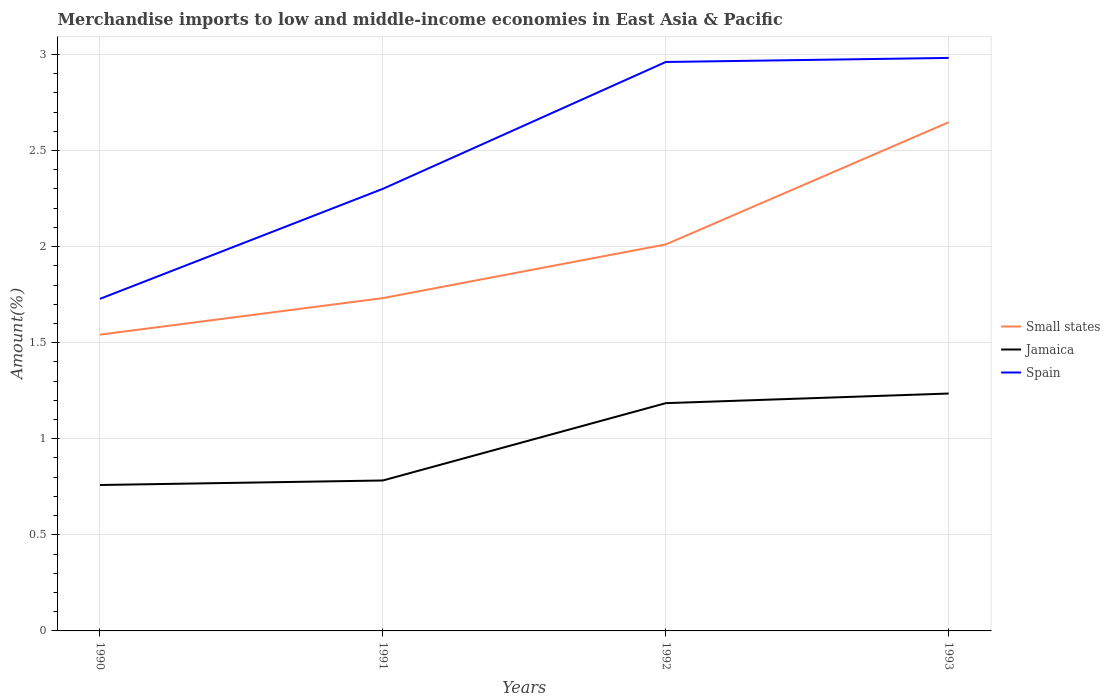Does the line corresponding to Small states intersect with the line corresponding to Spain?
Give a very brief answer. No. Across all years, what is the maximum percentage of amount earned from merchandise imports in Jamaica?
Provide a succinct answer. 0.76. What is the total percentage of amount earned from merchandise imports in Spain in the graph?
Your response must be concise. -0.68. What is the difference between the highest and the second highest percentage of amount earned from merchandise imports in Small states?
Provide a short and direct response. 1.11. What is the difference between two consecutive major ticks on the Y-axis?
Ensure brevity in your answer.  0.5. Are the values on the major ticks of Y-axis written in scientific E-notation?
Your answer should be very brief. No. Does the graph contain any zero values?
Offer a terse response. No. How many legend labels are there?
Give a very brief answer. 3. What is the title of the graph?
Your response must be concise. Merchandise imports to low and middle-income economies in East Asia & Pacific. Does "Albania" appear as one of the legend labels in the graph?
Provide a short and direct response. No. What is the label or title of the Y-axis?
Your response must be concise. Amount(%). What is the Amount(%) in Small states in 1990?
Ensure brevity in your answer.  1.54. What is the Amount(%) of Jamaica in 1990?
Keep it short and to the point. 0.76. What is the Amount(%) in Spain in 1990?
Provide a succinct answer. 1.73. What is the Amount(%) in Small states in 1991?
Offer a very short reply. 1.73. What is the Amount(%) of Jamaica in 1991?
Offer a terse response. 0.78. What is the Amount(%) of Spain in 1991?
Offer a terse response. 2.3. What is the Amount(%) in Small states in 1992?
Ensure brevity in your answer.  2.01. What is the Amount(%) in Jamaica in 1992?
Offer a terse response. 1.19. What is the Amount(%) of Spain in 1992?
Make the answer very short. 2.96. What is the Amount(%) in Small states in 1993?
Your response must be concise. 2.65. What is the Amount(%) of Jamaica in 1993?
Your answer should be very brief. 1.24. What is the Amount(%) of Spain in 1993?
Your answer should be compact. 2.98. Across all years, what is the maximum Amount(%) of Small states?
Offer a terse response. 2.65. Across all years, what is the maximum Amount(%) in Jamaica?
Provide a short and direct response. 1.24. Across all years, what is the maximum Amount(%) in Spain?
Give a very brief answer. 2.98. Across all years, what is the minimum Amount(%) in Small states?
Keep it short and to the point. 1.54. Across all years, what is the minimum Amount(%) of Jamaica?
Offer a very short reply. 0.76. Across all years, what is the minimum Amount(%) in Spain?
Ensure brevity in your answer.  1.73. What is the total Amount(%) in Small states in the graph?
Your answer should be compact. 7.93. What is the total Amount(%) of Jamaica in the graph?
Your response must be concise. 3.96. What is the total Amount(%) in Spain in the graph?
Keep it short and to the point. 9.97. What is the difference between the Amount(%) of Small states in 1990 and that in 1991?
Your response must be concise. -0.19. What is the difference between the Amount(%) in Jamaica in 1990 and that in 1991?
Your response must be concise. -0.02. What is the difference between the Amount(%) in Spain in 1990 and that in 1991?
Make the answer very short. -0.57. What is the difference between the Amount(%) of Small states in 1990 and that in 1992?
Provide a short and direct response. -0.47. What is the difference between the Amount(%) in Jamaica in 1990 and that in 1992?
Provide a short and direct response. -0.43. What is the difference between the Amount(%) of Spain in 1990 and that in 1992?
Ensure brevity in your answer.  -1.23. What is the difference between the Amount(%) of Small states in 1990 and that in 1993?
Ensure brevity in your answer.  -1.11. What is the difference between the Amount(%) of Jamaica in 1990 and that in 1993?
Make the answer very short. -0.48. What is the difference between the Amount(%) in Spain in 1990 and that in 1993?
Make the answer very short. -1.25. What is the difference between the Amount(%) of Small states in 1991 and that in 1992?
Give a very brief answer. -0.28. What is the difference between the Amount(%) in Jamaica in 1991 and that in 1992?
Provide a succinct answer. -0.4. What is the difference between the Amount(%) in Spain in 1991 and that in 1992?
Provide a succinct answer. -0.66. What is the difference between the Amount(%) in Small states in 1991 and that in 1993?
Offer a very short reply. -0.92. What is the difference between the Amount(%) of Jamaica in 1991 and that in 1993?
Provide a succinct answer. -0.45. What is the difference between the Amount(%) in Spain in 1991 and that in 1993?
Keep it short and to the point. -0.68. What is the difference between the Amount(%) in Small states in 1992 and that in 1993?
Your answer should be very brief. -0.64. What is the difference between the Amount(%) of Jamaica in 1992 and that in 1993?
Ensure brevity in your answer.  -0.05. What is the difference between the Amount(%) of Spain in 1992 and that in 1993?
Your response must be concise. -0.02. What is the difference between the Amount(%) of Small states in 1990 and the Amount(%) of Jamaica in 1991?
Offer a terse response. 0.76. What is the difference between the Amount(%) of Small states in 1990 and the Amount(%) of Spain in 1991?
Keep it short and to the point. -0.76. What is the difference between the Amount(%) of Jamaica in 1990 and the Amount(%) of Spain in 1991?
Provide a short and direct response. -1.54. What is the difference between the Amount(%) of Small states in 1990 and the Amount(%) of Jamaica in 1992?
Offer a very short reply. 0.36. What is the difference between the Amount(%) of Small states in 1990 and the Amount(%) of Spain in 1992?
Make the answer very short. -1.42. What is the difference between the Amount(%) in Jamaica in 1990 and the Amount(%) in Spain in 1992?
Your answer should be compact. -2.2. What is the difference between the Amount(%) of Small states in 1990 and the Amount(%) of Jamaica in 1993?
Your answer should be compact. 0.31. What is the difference between the Amount(%) of Small states in 1990 and the Amount(%) of Spain in 1993?
Ensure brevity in your answer.  -1.44. What is the difference between the Amount(%) in Jamaica in 1990 and the Amount(%) in Spain in 1993?
Make the answer very short. -2.22. What is the difference between the Amount(%) in Small states in 1991 and the Amount(%) in Jamaica in 1992?
Ensure brevity in your answer.  0.55. What is the difference between the Amount(%) of Small states in 1991 and the Amount(%) of Spain in 1992?
Your answer should be very brief. -1.23. What is the difference between the Amount(%) in Jamaica in 1991 and the Amount(%) in Spain in 1992?
Make the answer very short. -2.18. What is the difference between the Amount(%) of Small states in 1991 and the Amount(%) of Jamaica in 1993?
Ensure brevity in your answer.  0.5. What is the difference between the Amount(%) in Small states in 1991 and the Amount(%) in Spain in 1993?
Make the answer very short. -1.25. What is the difference between the Amount(%) in Jamaica in 1991 and the Amount(%) in Spain in 1993?
Offer a terse response. -2.2. What is the difference between the Amount(%) of Small states in 1992 and the Amount(%) of Jamaica in 1993?
Offer a very short reply. 0.78. What is the difference between the Amount(%) of Small states in 1992 and the Amount(%) of Spain in 1993?
Provide a short and direct response. -0.97. What is the difference between the Amount(%) in Jamaica in 1992 and the Amount(%) in Spain in 1993?
Give a very brief answer. -1.8. What is the average Amount(%) of Small states per year?
Ensure brevity in your answer.  1.98. What is the average Amount(%) of Spain per year?
Your answer should be very brief. 2.49. In the year 1990, what is the difference between the Amount(%) of Small states and Amount(%) of Jamaica?
Your response must be concise. 0.78. In the year 1990, what is the difference between the Amount(%) in Small states and Amount(%) in Spain?
Keep it short and to the point. -0.19. In the year 1990, what is the difference between the Amount(%) in Jamaica and Amount(%) in Spain?
Make the answer very short. -0.97. In the year 1991, what is the difference between the Amount(%) of Small states and Amount(%) of Jamaica?
Ensure brevity in your answer.  0.95. In the year 1991, what is the difference between the Amount(%) in Small states and Amount(%) in Spain?
Your answer should be compact. -0.57. In the year 1991, what is the difference between the Amount(%) of Jamaica and Amount(%) of Spain?
Your answer should be compact. -1.52. In the year 1992, what is the difference between the Amount(%) of Small states and Amount(%) of Jamaica?
Offer a terse response. 0.83. In the year 1992, what is the difference between the Amount(%) in Small states and Amount(%) in Spain?
Make the answer very short. -0.95. In the year 1992, what is the difference between the Amount(%) in Jamaica and Amount(%) in Spain?
Your answer should be very brief. -1.78. In the year 1993, what is the difference between the Amount(%) of Small states and Amount(%) of Jamaica?
Your answer should be very brief. 1.41. In the year 1993, what is the difference between the Amount(%) of Small states and Amount(%) of Spain?
Your answer should be compact. -0.33. In the year 1993, what is the difference between the Amount(%) of Jamaica and Amount(%) of Spain?
Your answer should be compact. -1.75. What is the ratio of the Amount(%) in Small states in 1990 to that in 1991?
Offer a terse response. 0.89. What is the ratio of the Amount(%) of Spain in 1990 to that in 1991?
Your response must be concise. 0.75. What is the ratio of the Amount(%) of Small states in 1990 to that in 1992?
Make the answer very short. 0.77. What is the ratio of the Amount(%) of Jamaica in 1990 to that in 1992?
Your answer should be compact. 0.64. What is the ratio of the Amount(%) of Spain in 1990 to that in 1992?
Offer a terse response. 0.58. What is the ratio of the Amount(%) in Small states in 1990 to that in 1993?
Your response must be concise. 0.58. What is the ratio of the Amount(%) in Jamaica in 1990 to that in 1993?
Your response must be concise. 0.61. What is the ratio of the Amount(%) of Spain in 1990 to that in 1993?
Give a very brief answer. 0.58. What is the ratio of the Amount(%) in Small states in 1991 to that in 1992?
Offer a terse response. 0.86. What is the ratio of the Amount(%) in Jamaica in 1991 to that in 1992?
Offer a terse response. 0.66. What is the ratio of the Amount(%) in Spain in 1991 to that in 1992?
Provide a short and direct response. 0.78. What is the ratio of the Amount(%) of Small states in 1991 to that in 1993?
Offer a very short reply. 0.65. What is the ratio of the Amount(%) in Jamaica in 1991 to that in 1993?
Your answer should be very brief. 0.63. What is the ratio of the Amount(%) of Spain in 1991 to that in 1993?
Ensure brevity in your answer.  0.77. What is the ratio of the Amount(%) in Small states in 1992 to that in 1993?
Offer a terse response. 0.76. What is the ratio of the Amount(%) of Jamaica in 1992 to that in 1993?
Provide a succinct answer. 0.96. What is the ratio of the Amount(%) of Spain in 1992 to that in 1993?
Give a very brief answer. 0.99. What is the difference between the highest and the second highest Amount(%) of Small states?
Give a very brief answer. 0.64. What is the difference between the highest and the second highest Amount(%) of Jamaica?
Provide a short and direct response. 0.05. What is the difference between the highest and the second highest Amount(%) in Spain?
Make the answer very short. 0.02. What is the difference between the highest and the lowest Amount(%) in Small states?
Give a very brief answer. 1.11. What is the difference between the highest and the lowest Amount(%) of Jamaica?
Provide a succinct answer. 0.48. What is the difference between the highest and the lowest Amount(%) in Spain?
Your response must be concise. 1.25. 